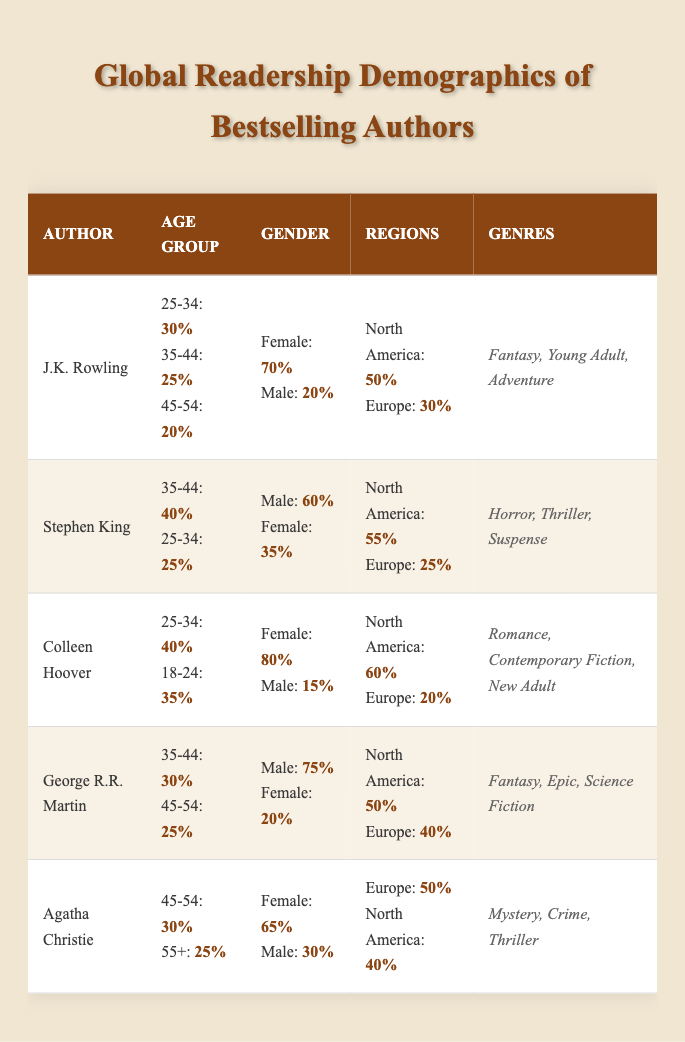What is the most popular age group among J.K. Rowling's readers? Referring to the table, J.K. Rowling's highest percentage in an age group is 30% for the 25-34 group.
Answer: 25-34 Which author has the highest percentage of female readers? Looking at the gender demographics, Colleen Hoover has the highest percentage of female readers at 80%.
Answer: Colleen Hoover What is the total percentage of readers from North America for Stephen King? According to the table, Stephen King's readers from North America comprise 55%.
Answer: 55% Which genres are most common among George R.R. Martin's readership? The table lists George R.R. Martin's genres as Fantasy, Epic, and Science Fiction.
Answer: Fantasy, Epic, Science Fiction How many percent of Agatha Christie's readers are in the 45-54 age group? The table indicates that 30% of Agatha Christie's readers are in the 45-54 age group.
Answer: 30% Is there a higher percentage of male readers for George R.R. Martin or Stephen King? George R.R. Martin has 75% male readers, while Stephen King has 60%. Thus, George R.R. Martin has a higher percentage.
Answer: George R.R. Martin What is the average percentage of readers aged 18-24 across all authors? The percentages are 15% (J.K. Rowling), 10% (Stephen King), 35% (Colleen Hoover), 5% (George R.R. Martin), and 5% (Agatha Christie). Their total is 15 + 10 + 35 + 5 + 5 = 70, and dividing by 5 gives 70/5 = 14%.
Answer: 14% Which author has the least percentage of readership in Asia? The table shows that George R.R. Martin has only 5% of readership in Asia, which is the lowest percentage.
Answer: George R.R. Martin What is the gender ratio of J.K. Rowling's readers? J.K. Rowling's readers consist of 70% female and 20% male. The ratio can be simplified as 70:20 or 7:2.
Answer: 7:2 For Colleen Hoover, what percentage of readers are aged 35-44? The table states that only 15% of Colleen Hoover's readers are in the 35-44 age group.
Answer: 15% 